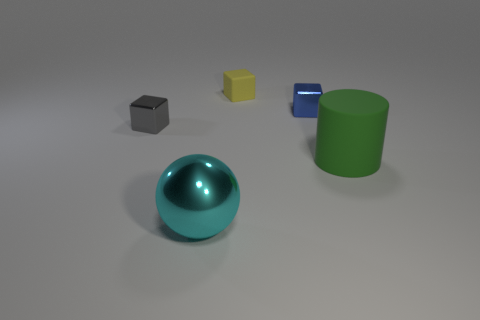What do you think the context or purpose of this image could be? This image appears to be a 3D rendering or a staged photograph used for illustrative or educational purposes. The variety in shapes and colors might suggest that it's used to teach concepts of geometry or color theory. Additionally, given the pristine condition and orderly arrangement of the objects, it could also be part of a visual composition study in art or a product display in a design context. 